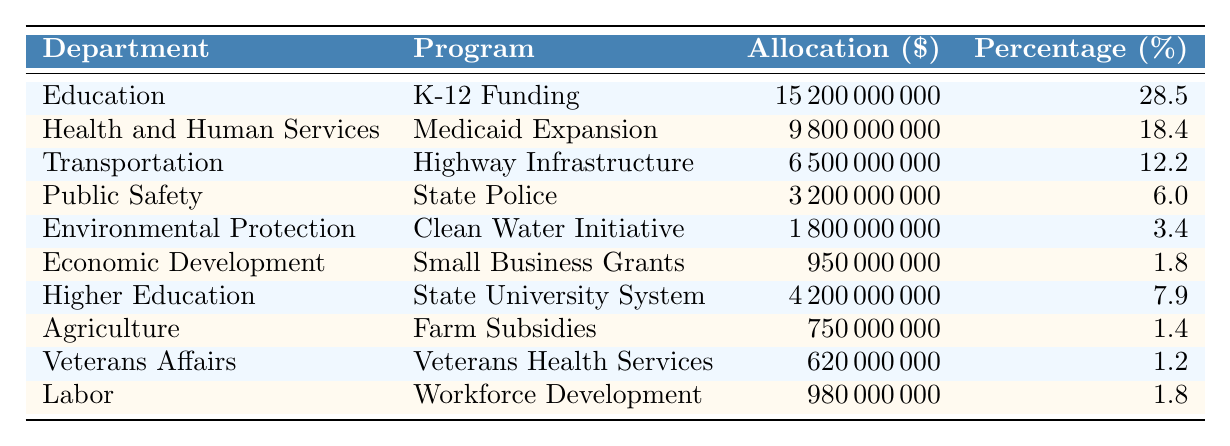What is the total budget allocation for Education? The table shows that the allocation for the Education department is 15,200,000,000. Therefore, the total budget allocation for Education is this value.
Answer: 15,200,000,000 Which department received the second highest percentage of the budget? Looking at the percentage column, Health and Human Services has 18.4%, which is the second highest after Education's 28.5%.
Answer: Health and Human Services What is the total allocation for Health and Human Services and Public Safety combined? Adding the allocations for Health and Human Services (9,800,000,000) and Public Safety (3,200,000,000) gives 9,800,000,000 + 3,200,000,000 = 13,000,000,000.
Answer: 13,000,000,000 What percentage of the total budget is allocated to Environmental Protection? The allocation for Environmental Protection is 1,800,000,000. To find the percentage, we can use the allocation divided by the total budget (which is the sum of all allocations) multiplied by 100. The total budget is 53,430,000,000. Calculation: (1,800,000,000 / 53,430,000,000) * 100 = approximately 3.4%.
Answer: 3.4% Is the budget allocation for Veterans Affairs greater than that for Agriculture? The allocation for Veterans Affairs is 620,000,000 and for Agriculture is 750,000,000. Comparing both, Veterans Affairs has less allocation than Agriculture (620,000,000 < 750,000,000).
Answer: No What is the average allocation of all departments? First, sum all allocations to get a total of 53,430,000,000. Since there are 10 departments, divide the total by 10: 53,430,000,000 / 10 = 5,343,000,000.
Answer: 5,343,000,000 How much more funding is allocated to K-12 Funding compared to Small Business Grants? The allocation for K-12 Funding is 15,200,000,000 and for Small Business Grants is 950,000,000. Subtracting gives 15,200,000,000 - 950,000,000 = 14,250,000,000.
Answer: 14,250,000,000 Which program has the smallest budget allocation? Looking at the allocation column, the program with the smallest allocation is Veterans Health Services with 620,000,000.
Answer: Veterans Health Services If we combine the allocations for Transportation and Economic Development, what percentage of the total budget does that represent? The allocation for Transportation is 6,500,000,000 and for Economic Development is 950,000,000. Combined, that gives 6,500,000,000 + 950,000,000 = 7,450,000,000. To find the percentage, use 7,450,000,000 / 53,430,000,000 * 100 which is approximately 13.92%.
Answer: Approximately 13.92% What fraction of the total budget is allocated to Higher Education? The allocation for Higher Education is 4,200,000,000. First, find the total budget of 53,430,000,000, then the fraction is 4,200,000,000 / 53,430,000,000 = approximately 0.0786.
Answer: Approximately 0.0786 